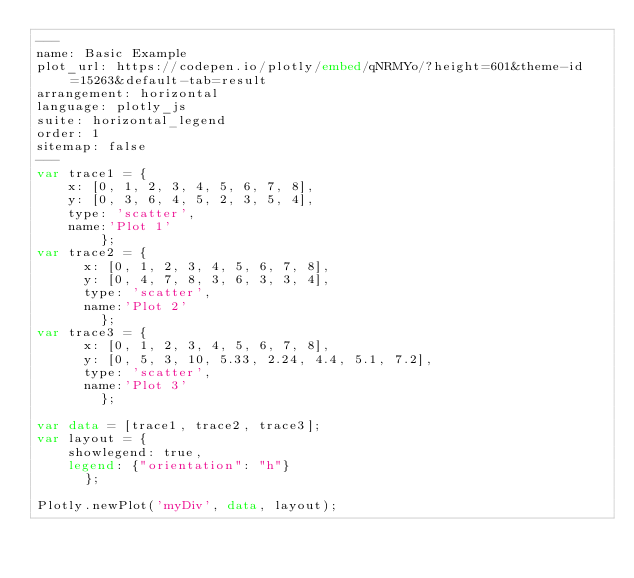<code> <loc_0><loc_0><loc_500><loc_500><_HTML_>---
name: Basic Example
plot_url: https://codepen.io/plotly/embed/qNRMYo/?height=601&theme-id=15263&default-tab=result
arrangement: horizontal
language: plotly_js
suite: horizontal_legend
order: 1
sitemap: false
---
var trace1 = {
		x: [0, 1, 2, 3, 4, 5, 6, 7, 8],
		y: [0, 3, 6, 4, 5, 2, 3, 5, 4],
		type: 'scatter',
		name:'Plot 1'
        };
var trace2 = {
	    x: [0, 1, 2, 3, 4, 5, 6, 7, 8],
	    y: [0, 4, 7, 8, 3, 6, 3, 3, 4],
	    type: 'scatter',
	    name:'Plot 2'
        };
var trace3 = {
	    x: [0, 1, 2, 3, 4, 5, 6, 7, 8],
	    y: [0, 5, 3, 10, 5.33, 2.24, 4.4, 5.1, 7.2],
	    type: 'scatter',
	    name:'Plot 3'
        };

var data = [trace1, trace2, trace3];
var layout = {
		showlegend: true,
		legend: {"orientation": "h"}
	    };
 
Plotly.newPlot('myDiv', data, layout);</code> 